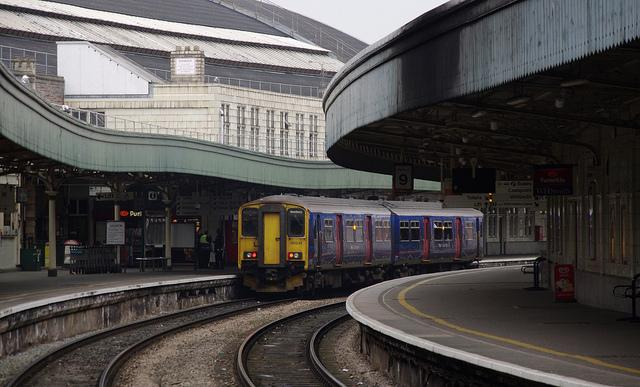Why is the yellow line painted on the ground? Please explain your reasoning. safety. The line is for safety. 